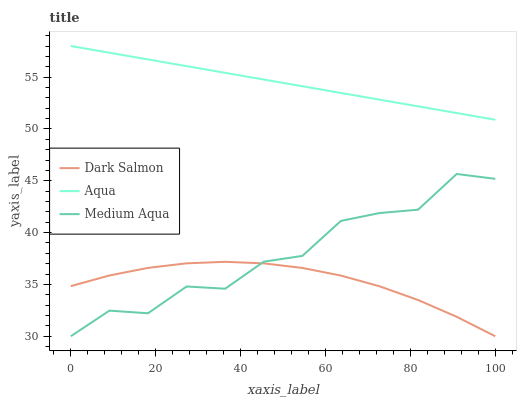Does Dark Salmon have the minimum area under the curve?
Answer yes or no. Yes. Does Aqua have the maximum area under the curve?
Answer yes or no. Yes. Does Aqua have the minimum area under the curve?
Answer yes or no. No. Does Dark Salmon have the maximum area under the curve?
Answer yes or no. No. Is Aqua the smoothest?
Answer yes or no. Yes. Is Medium Aqua the roughest?
Answer yes or no. Yes. Is Dark Salmon the smoothest?
Answer yes or no. No. Is Dark Salmon the roughest?
Answer yes or no. No. Does Medium Aqua have the lowest value?
Answer yes or no. Yes. Does Aqua have the lowest value?
Answer yes or no. No. Does Aqua have the highest value?
Answer yes or no. Yes. Does Dark Salmon have the highest value?
Answer yes or no. No. Is Medium Aqua less than Aqua?
Answer yes or no. Yes. Is Aqua greater than Dark Salmon?
Answer yes or no. Yes. Does Dark Salmon intersect Medium Aqua?
Answer yes or no. Yes. Is Dark Salmon less than Medium Aqua?
Answer yes or no. No. Is Dark Salmon greater than Medium Aqua?
Answer yes or no. No. Does Medium Aqua intersect Aqua?
Answer yes or no. No. 